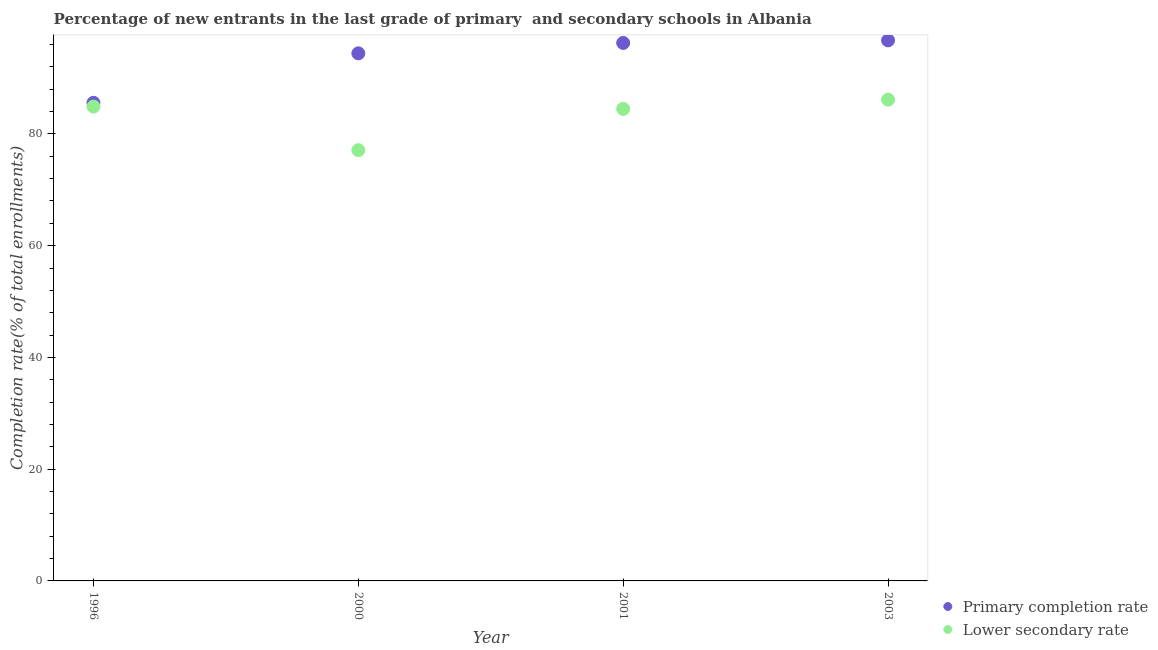Is the number of dotlines equal to the number of legend labels?
Offer a very short reply. Yes. What is the completion rate in secondary schools in 2000?
Provide a succinct answer. 77.09. Across all years, what is the maximum completion rate in secondary schools?
Offer a terse response. 86.14. Across all years, what is the minimum completion rate in primary schools?
Provide a short and direct response. 85.57. What is the total completion rate in primary schools in the graph?
Keep it short and to the point. 373.03. What is the difference between the completion rate in primary schools in 2000 and that in 2003?
Your answer should be compact. -2.32. What is the difference between the completion rate in primary schools in 2003 and the completion rate in secondary schools in 2000?
Keep it short and to the point. 19.66. What is the average completion rate in primary schools per year?
Your answer should be compact. 93.26. In the year 2000, what is the difference between the completion rate in primary schools and completion rate in secondary schools?
Provide a short and direct response. 17.34. What is the ratio of the completion rate in primary schools in 1996 to that in 2001?
Offer a terse response. 0.89. Is the difference between the completion rate in secondary schools in 2001 and 2003 greater than the difference between the completion rate in primary schools in 2001 and 2003?
Offer a terse response. No. What is the difference between the highest and the second highest completion rate in secondary schools?
Provide a short and direct response. 1.24. What is the difference between the highest and the lowest completion rate in primary schools?
Your answer should be very brief. 11.18. Is the sum of the completion rate in primary schools in 1996 and 2000 greater than the maximum completion rate in secondary schools across all years?
Your response must be concise. Yes. Does the completion rate in primary schools monotonically increase over the years?
Keep it short and to the point. Yes. Is the completion rate in secondary schools strictly greater than the completion rate in primary schools over the years?
Your response must be concise. No. Is the completion rate in primary schools strictly less than the completion rate in secondary schools over the years?
Your response must be concise. No. What is the difference between two consecutive major ticks on the Y-axis?
Keep it short and to the point. 20. Are the values on the major ticks of Y-axis written in scientific E-notation?
Your response must be concise. No. Does the graph contain any zero values?
Make the answer very short. No. Does the graph contain grids?
Your response must be concise. No. How many legend labels are there?
Offer a terse response. 2. What is the title of the graph?
Your answer should be compact. Percentage of new entrants in the last grade of primary  and secondary schools in Albania. What is the label or title of the X-axis?
Offer a very short reply. Year. What is the label or title of the Y-axis?
Keep it short and to the point. Completion rate(% of total enrollments). What is the Completion rate(% of total enrollments) in Primary completion rate in 1996?
Provide a short and direct response. 85.57. What is the Completion rate(% of total enrollments) of Lower secondary rate in 1996?
Offer a terse response. 84.9. What is the Completion rate(% of total enrollments) in Primary completion rate in 2000?
Offer a terse response. 94.43. What is the Completion rate(% of total enrollments) of Lower secondary rate in 2000?
Provide a succinct answer. 77.09. What is the Completion rate(% of total enrollments) of Primary completion rate in 2001?
Offer a terse response. 96.29. What is the Completion rate(% of total enrollments) of Lower secondary rate in 2001?
Provide a short and direct response. 84.48. What is the Completion rate(% of total enrollments) of Primary completion rate in 2003?
Provide a short and direct response. 96.75. What is the Completion rate(% of total enrollments) in Lower secondary rate in 2003?
Keep it short and to the point. 86.14. Across all years, what is the maximum Completion rate(% of total enrollments) in Primary completion rate?
Make the answer very short. 96.75. Across all years, what is the maximum Completion rate(% of total enrollments) of Lower secondary rate?
Give a very brief answer. 86.14. Across all years, what is the minimum Completion rate(% of total enrollments) of Primary completion rate?
Your response must be concise. 85.57. Across all years, what is the minimum Completion rate(% of total enrollments) in Lower secondary rate?
Your answer should be compact. 77.09. What is the total Completion rate(% of total enrollments) in Primary completion rate in the graph?
Your response must be concise. 373.03. What is the total Completion rate(% of total enrollments) of Lower secondary rate in the graph?
Ensure brevity in your answer.  332.61. What is the difference between the Completion rate(% of total enrollments) of Primary completion rate in 1996 and that in 2000?
Give a very brief answer. -8.86. What is the difference between the Completion rate(% of total enrollments) of Lower secondary rate in 1996 and that in 2000?
Your answer should be compact. 7.81. What is the difference between the Completion rate(% of total enrollments) of Primary completion rate in 1996 and that in 2001?
Ensure brevity in your answer.  -10.71. What is the difference between the Completion rate(% of total enrollments) of Lower secondary rate in 1996 and that in 2001?
Offer a very short reply. 0.42. What is the difference between the Completion rate(% of total enrollments) of Primary completion rate in 1996 and that in 2003?
Keep it short and to the point. -11.18. What is the difference between the Completion rate(% of total enrollments) of Lower secondary rate in 1996 and that in 2003?
Offer a terse response. -1.24. What is the difference between the Completion rate(% of total enrollments) of Primary completion rate in 2000 and that in 2001?
Your answer should be compact. -1.86. What is the difference between the Completion rate(% of total enrollments) in Lower secondary rate in 2000 and that in 2001?
Ensure brevity in your answer.  -7.39. What is the difference between the Completion rate(% of total enrollments) in Primary completion rate in 2000 and that in 2003?
Your response must be concise. -2.32. What is the difference between the Completion rate(% of total enrollments) in Lower secondary rate in 2000 and that in 2003?
Provide a succinct answer. -9.05. What is the difference between the Completion rate(% of total enrollments) of Primary completion rate in 2001 and that in 2003?
Ensure brevity in your answer.  -0.46. What is the difference between the Completion rate(% of total enrollments) of Lower secondary rate in 2001 and that in 2003?
Provide a succinct answer. -1.66. What is the difference between the Completion rate(% of total enrollments) of Primary completion rate in 1996 and the Completion rate(% of total enrollments) of Lower secondary rate in 2000?
Offer a very short reply. 8.48. What is the difference between the Completion rate(% of total enrollments) of Primary completion rate in 1996 and the Completion rate(% of total enrollments) of Lower secondary rate in 2001?
Your answer should be compact. 1.09. What is the difference between the Completion rate(% of total enrollments) of Primary completion rate in 1996 and the Completion rate(% of total enrollments) of Lower secondary rate in 2003?
Your answer should be very brief. -0.57. What is the difference between the Completion rate(% of total enrollments) of Primary completion rate in 2000 and the Completion rate(% of total enrollments) of Lower secondary rate in 2001?
Ensure brevity in your answer.  9.95. What is the difference between the Completion rate(% of total enrollments) in Primary completion rate in 2000 and the Completion rate(% of total enrollments) in Lower secondary rate in 2003?
Your answer should be very brief. 8.29. What is the difference between the Completion rate(% of total enrollments) in Primary completion rate in 2001 and the Completion rate(% of total enrollments) in Lower secondary rate in 2003?
Your response must be concise. 10.15. What is the average Completion rate(% of total enrollments) in Primary completion rate per year?
Keep it short and to the point. 93.26. What is the average Completion rate(% of total enrollments) of Lower secondary rate per year?
Your answer should be very brief. 83.15. In the year 1996, what is the difference between the Completion rate(% of total enrollments) in Primary completion rate and Completion rate(% of total enrollments) in Lower secondary rate?
Your answer should be very brief. 0.67. In the year 2000, what is the difference between the Completion rate(% of total enrollments) in Primary completion rate and Completion rate(% of total enrollments) in Lower secondary rate?
Keep it short and to the point. 17.34. In the year 2001, what is the difference between the Completion rate(% of total enrollments) of Primary completion rate and Completion rate(% of total enrollments) of Lower secondary rate?
Ensure brevity in your answer.  11.8. In the year 2003, what is the difference between the Completion rate(% of total enrollments) in Primary completion rate and Completion rate(% of total enrollments) in Lower secondary rate?
Provide a succinct answer. 10.61. What is the ratio of the Completion rate(% of total enrollments) in Primary completion rate in 1996 to that in 2000?
Provide a succinct answer. 0.91. What is the ratio of the Completion rate(% of total enrollments) of Lower secondary rate in 1996 to that in 2000?
Keep it short and to the point. 1.1. What is the ratio of the Completion rate(% of total enrollments) of Primary completion rate in 1996 to that in 2001?
Provide a succinct answer. 0.89. What is the ratio of the Completion rate(% of total enrollments) in Primary completion rate in 1996 to that in 2003?
Provide a short and direct response. 0.88. What is the ratio of the Completion rate(% of total enrollments) in Lower secondary rate in 1996 to that in 2003?
Keep it short and to the point. 0.99. What is the ratio of the Completion rate(% of total enrollments) of Primary completion rate in 2000 to that in 2001?
Provide a succinct answer. 0.98. What is the ratio of the Completion rate(% of total enrollments) of Lower secondary rate in 2000 to that in 2001?
Offer a terse response. 0.91. What is the ratio of the Completion rate(% of total enrollments) of Primary completion rate in 2000 to that in 2003?
Keep it short and to the point. 0.98. What is the ratio of the Completion rate(% of total enrollments) in Lower secondary rate in 2000 to that in 2003?
Ensure brevity in your answer.  0.89. What is the ratio of the Completion rate(% of total enrollments) in Lower secondary rate in 2001 to that in 2003?
Your response must be concise. 0.98. What is the difference between the highest and the second highest Completion rate(% of total enrollments) of Primary completion rate?
Offer a very short reply. 0.46. What is the difference between the highest and the second highest Completion rate(% of total enrollments) in Lower secondary rate?
Offer a terse response. 1.24. What is the difference between the highest and the lowest Completion rate(% of total enrollments) in Primary completion rate?
Your response must be concise. 11.18. What is the difference between the highest and the lowest Completion rate(% of total enrollments) in Lower secondary rate?
Give a very brief answer. 9.05. 